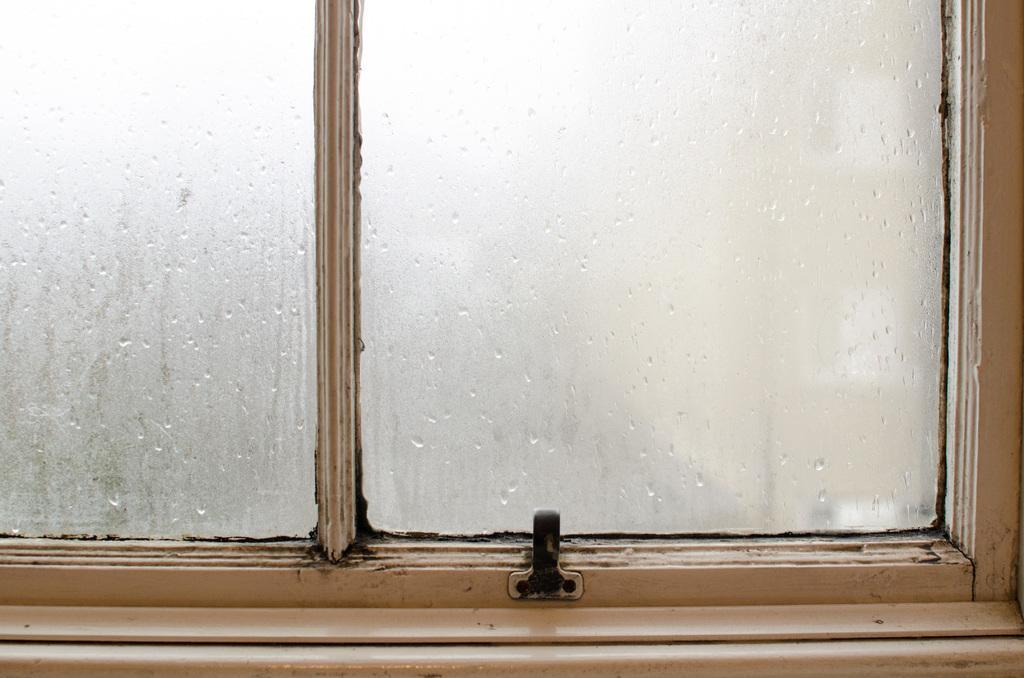Could you give a brief overview of what you see in this image? There is a window with glass panels. On the glass there are water droplets. 